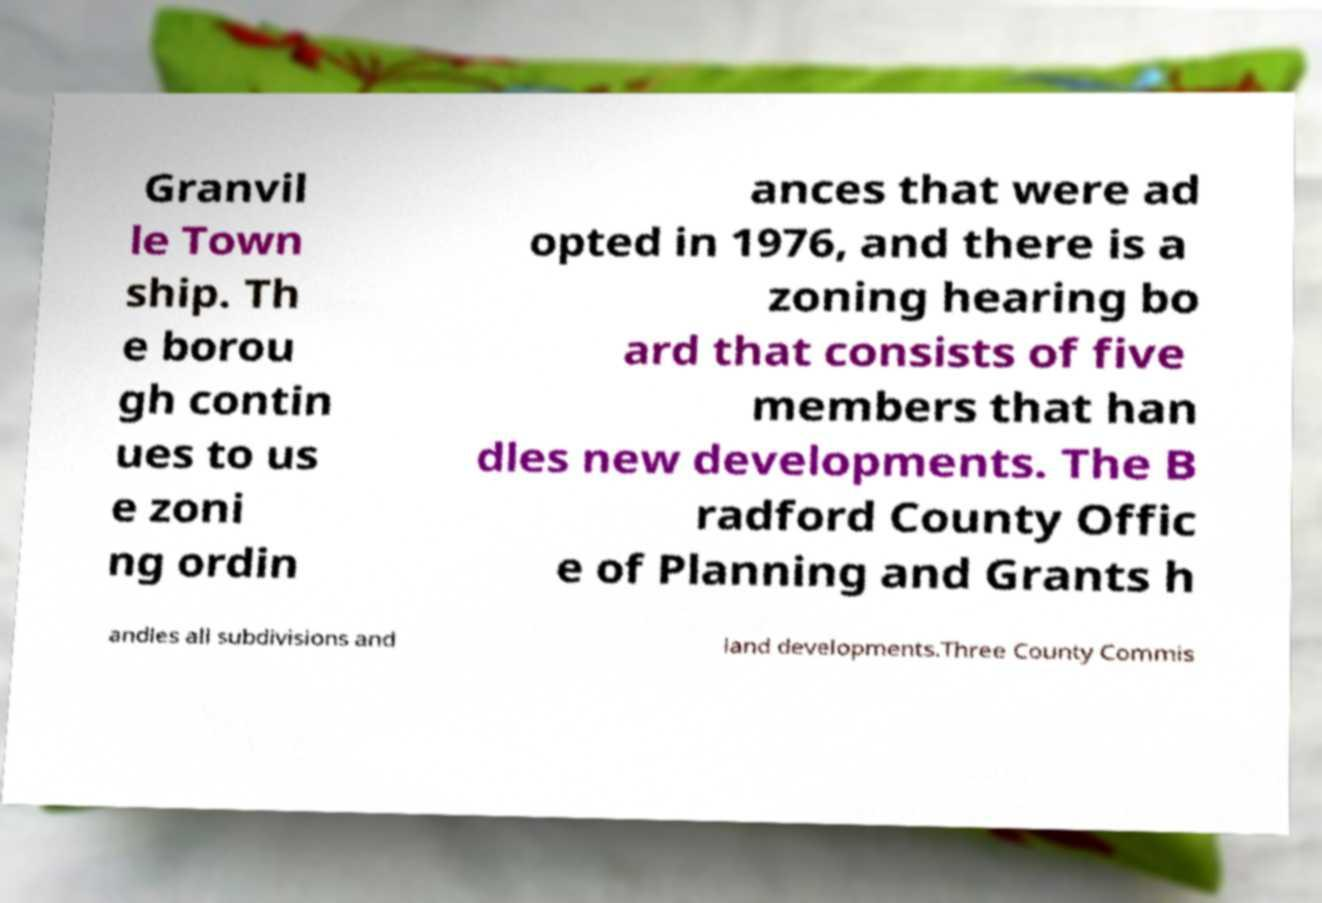Could you extract and type out the text from this image? Granvil le Town ship. Th e borou gh contin ues to us e zoni ng ordin ances that were ad opted in 1976, and there is a zoning hearing bo ard that consists of five members that han dles new developments. The B radford County Offic e of Planning and Grants h andles all subdivisions and land developments.Three County Commis 